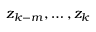<formula> <loc_0><loc_0><loc_500><loc_500>z _ { k - m } , \dots , z _ { k }</formula> 